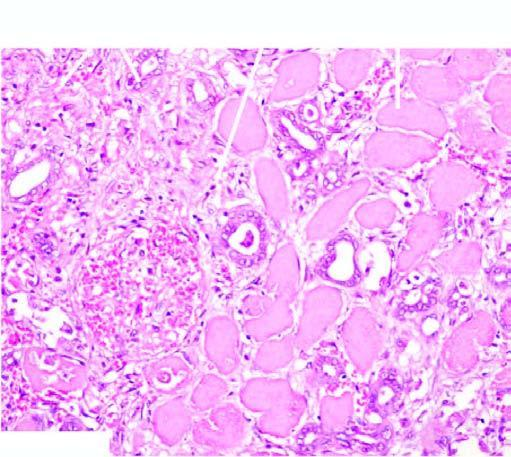does sequence of events in the pathogenesis of reversible and irreversible cell injury show typical coagulative necrosis ie?
Answer the question using a single word or phrase. No 